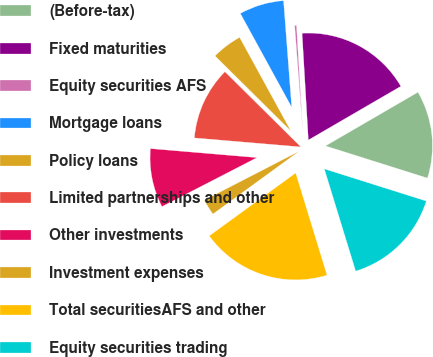Convert chart to OTSL. <chart><loc_0><loc_0><loc_500><loc_500><pie_chart><fcel>(Before-tax)<fcel>Fixed maturities<fcel>Equity securities AFS<fcel>Mortgage loans<fcel>Policy loans<fcel>Limited partnerships and other<fcel>Other investments<fcel>Investment expenses<fcel>Total securitiesAFS and other<fcel>Equity securities trading<nl><fcel>13.24%<fcel>17.56%<fcel>0.28%<fcel>6.76%<fcel>4.6%<fcel>11.08%<fcel>8.92%<fcel>2.44%<fcel>19.72%<fcel>15.4%<nl></chart> 